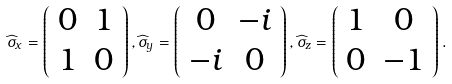<formula> <loc_0><loc_0><loc_500><loc_500>\widehat { \sigma } _ { x } = \left ( \begin{array} { c c } 0 & 1 \\ 1 & 0 \end{array} \right ) , \widehat { \sigma } _ { y } = \left ( \begin{array} { c c } 0 & - i \\ - i & 0 \end{array} \right ) , \widehat { \sigma } _ { z } = \left ( \begin{array} { c c } 1 & 0 \\ 0 & - 1 \end{array} \right ) .</formula> 